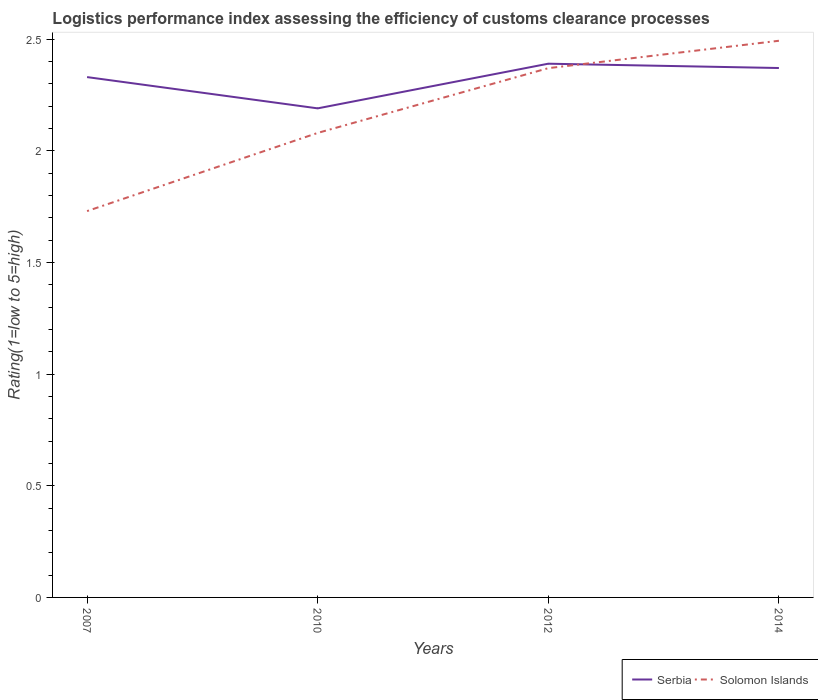Is the number of lines equal to the number of legend labels?
Offer a terse response. Yes. Across all years, what is the maximum Logistic performance index in Solomon Islands?
Provide a short and direct response. 1.73. In which year was the Logistic performance index in Solomon Islands maximum?
Your response must be concise. 2007. What is the total Logistic performance index in Solomon Islands in the graph?
Your answer should be very brief. -0.64. What is the difference between the highest and the second highest Logistic performance index in Solomon Islands?
Keep it short and to the point. 0.76. What is the difference between the highest and the lowest Logistic performance index in Solomon Islands?
Ensure brevity in your answer.  2. How many years are there in the graph?
Provide a short and direct response. 4. Does the graph contain any zero values?
Your answer should be compact. No. Does the graph contain grids?
Your response must be concise. No. How many legend labels are there?
Provide a succinct answer. 2. What is the title of the graph?
Your response must be concise. Logistics performance index assessing the efficiency of customs clearance processes. Does "Kazakhstan" appear as one of the legend labels in the graph?
Offer a terse response. No. What is the label or title of the X-axis?
Ensure brevity in your answer.  Years. What is the label or title of the Y-axis?
Ensure brevity in your answer.  Rating(1=low to 5=high). What is the Rating(1=low to 5=high) of Serbia in 2007?
Ensure brevity in your answer.  2.33. What is the Rating(1=low to 5=high) of Solomon Islands in 2007?
Keep it short and to the point. 1.73. What is the Rating(1=low to 5=high) of Serbia in 2010?
Provide a short and direct response. 2.19. What is the Rating(1=low to 5=high) in Solomon Islands in 2010?
Your response must be concise. 2.08. What is the Rating(1=low to 5=high) in Serbia in 2012?
Keep it short and to the point. 2.39. What is the Rating(1=low to 5=high) of Solomon Islands in 2012?
Offer a very short reply. 2.37. What is the Rating(1=low to 5=high) in Serbia in 2014?
Ensure brevity in your answer.  2.37. What is the Rating(1=low to 5=high) in Solomon Islands in 2014?
Make the answer very short. 2.49. Across all years, what is the maximum Rating(1=low to 5=high) in Serbia?
Offer a terse response. 2.39. Across all years, what is the maximum Rating(1=low to 5=high) of Solomon Islands?
Your answer should be very brief. 2.49. Across all years, what is the minimum Rating(1=low to 5=high) in Serbia?
Give a very brief answer. 2.19. Across all years, what is the minimum Rating(1=low to 5=high) in Solomon Islands?
Provide a succinct answer. 1.73. What is the total Rating(1=low to 5=high) in Serbia in the graph?
Provide a short and direct response. 9.28. What is the total Rating(1=low to 5=high) of Solomon Islands in the graph?
Ensure brevity in your answer.  8.67. What is the difference between the Rating(1=low to 5=high) of Serbia in 2007 and that in 2010?
Offer a terse response. 0.14. What is the difference between the Rating(1=low to 5=high) of Solomon Islands in 2007 and that in 2010?
Your answer should be compact. -0.35. What is the difference between the Rating(1=low to 5=high) of Serbia in 2007 and that in 2012?
Provide a short and direct response. -0.06. What is the difference between the Rating(1=low to 5=high) of Solomon Islands in 2007 and that in 2012?
Provide a succinct answer. -0.64. What is the difference between the Rating(1=low to 5=high) of Serbia in 2007 and that in 2014?
Provide a short and direct response. -0.04. What is the difference between the Rating(1=low to 5=high) of Solomon Islands in 2007 and that in 2014?
Keep it short and to the point. -0.76. What is the difference between the Rating(1=low to 5=high) in Solomon Islands in 2010 and that in 2012?
Ensure brevity in your answer.  -0.29. What is the difference between the Rating(1=low to 5=high) of Serbia in 2010 and that in 2014?
Ensure brevity in your answer.  -0.18. What is the difference between the Rating(1=low to 5=high) in Solomon Islands in 2010 and that in 2014?
Provide a succinct answer. -0.41. What is the difference between the Rating(1=low to 5=high) of Serbia in 2012 and that in 2014?
Your response must be concise. 0.02. What is the difference between the Rating(1=low to 5=high) of Solomon Islands in 2012 and that in 2014?
Your answer should be compact. -0.12. What is the difference between the Rating(1=low to 5=high) of Serbia in 2007 and the Rating(1=low to 5=high) of Solomon Islands in 2012?
Offer a terse response. -0.04. What is the difference between the Rating(1=low to 5=high) in Serbia in 2007 and the Rating(1=low to 5=high) in Solomon Islands in 2014?
Give a very brief answer. -0.16. What is the difference between the Rating(1=low to 5=high) of Serbia in 2010 and the Rating(1=low to 5=high) of Solomon Islands in 2012?
Make the answer very short. -0.18. What is the difference between the Rating(1=low to 5=high) of Serbia in 2010 and the Rating(1=low to 5=high) of Solomon Islands in 2014?
Offer a very short reply. -0.3. What is the difference between the Rating(1=low to 5=high) of Serbia in 2012 and the Rating(1=low to 5=high) of Solomon Islands in 2014?
Your answer should be very brief. -0.1. What is the average Rating(1=low to 5=high) of Serbia per year?
Provide a short and direct response. 2.32. What is the average Rating(1=low to 5=high) in Solomon Islands per year?
Your answer should be compact. 2.17. In the year 2010, what is the difference between the Rating(1=low to 5=high) in Serbia and Rating(1=low to 5=high) in Solomon Islands?
Offer a terse response. 0.11. In the year 2014, what is the difference between the Rating(1=low to 5=high) of Serbia and Rating(1=low to 5=high) of Solomon Islands?
Make the answer very short. -0.12. What is the ratio of the Rating(1=low to 5=high) in Serbia in 2007 to that in 2010?
Your answer should be very brief. 1.06. What is the ratio of the Rating(1=low to 5=high) of Solomon Islands in 2007 to that in 2010?
Your response must be concise. 0.83. What is the ratio of the Rating(1=low to 5=high) in Serbia in 2007 to that in 2012?
Offer a very short reply. 0.97. What is the ratio of the Rating(1=low to 5=high) of Solomon Islands in 2007 to that in 2012?
Offer a terse response. 0.73. What is the ratio of the Rating(1=low to 5=high) of Serbia in 2007 to that in 2014?
Make the answer very short. 0.98. What is the ratio of the Rating(1=low to 5=high) of Solomon Islands in 2007 to that in 2014?
Ensure brevity in your answer.  0.69. What is the ratio of the Rating(1=low to 5=high) of Serbia in 2010 to that in 2012?
Your response must be concise. 0.92. What is the ratio of the Rating(1=low to 5=high) of Solomon Islands in 2010 to that in 2012?
Your answer should be very brief. 0.88. What is the ratio of the Rating(1=low to 5=high) of Serbia in 2010 to that in 2014?
Give a very brief answer. 0.92. What is the ratio of the Rating(1=low to 5=high) of Solomon Islands in 2010 to that in 2014?
Make the answer very short. 0.83. What is the ratio of the Rating(1=low to 5=high) of Serbia in 2012 to that in 2014?
Offer a very short reply. 1.01. What is the ratio of the Rating(1=low to 5=high) of Solomon Islands in 2012 to that in 2014?
Ensure brevity in your answer.  0.95. What is the difference between the highest and the second highest Rating(1=low to 5=high) of Serbia?
Your answer should be very brief. 0.02. What is the difference between the highest and the second highest Rating(1=low to 5=high) in Solomon Islands?
Make the answer very short. 0.12. What is the difference between the highest and the lowest Rating(1=low to 5=high) of Solomon Islands?
Make the answer very short. 0.76. 